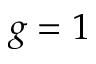<formula> <loc_0><loc_0><loc_500><loc_500>g = 1</formula> 